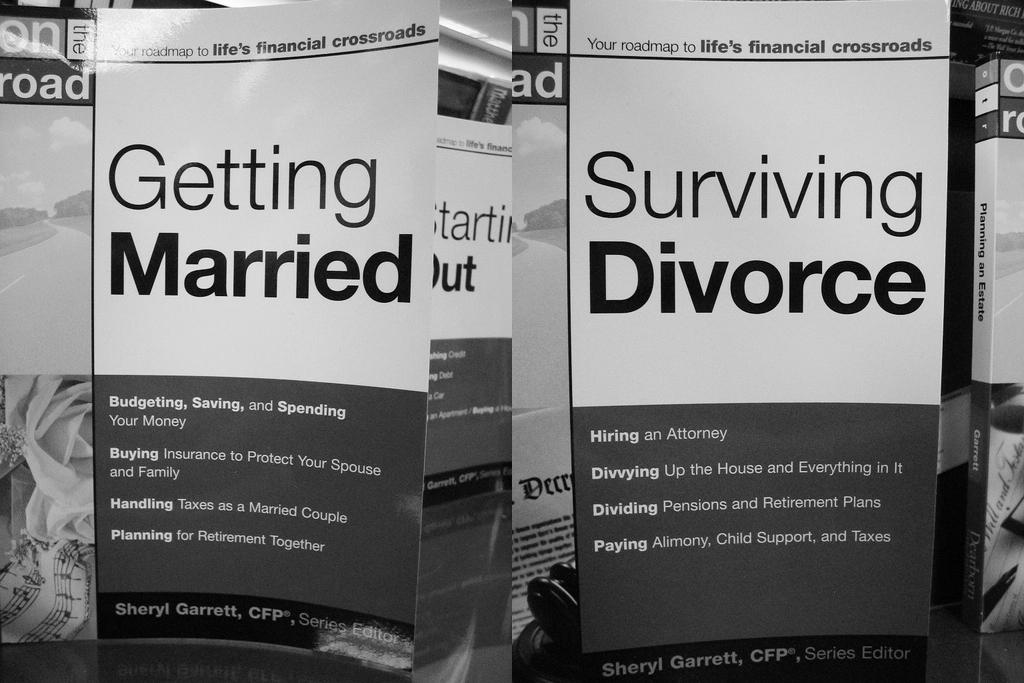Who wrote these books?
Your answer should be compact. Sheryl garrett. 